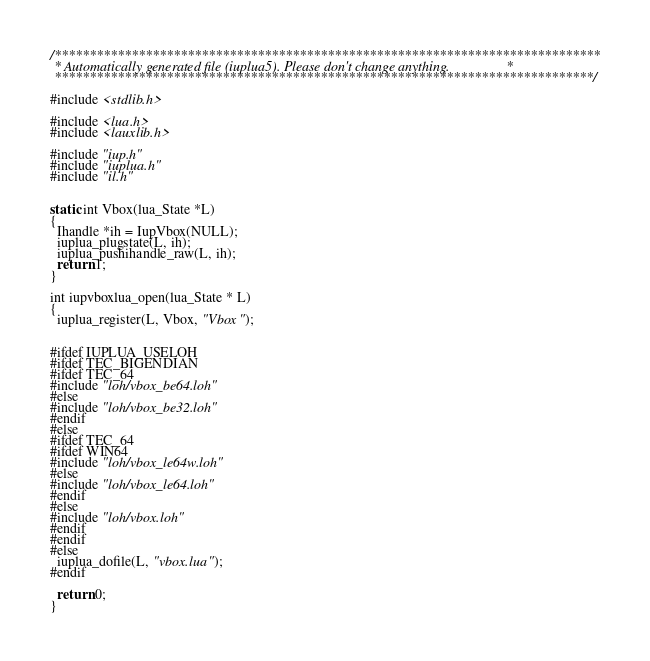<code> <loc_0><loc_0><loc_500><loc_500><_C_>/******************************************************************************
 * Automatically generated file (iuplua5). Please don't change anything.                *
 *****************************************************************************/

#include <stdlib.h>

#include <lua.h>
#include <lauxlib.h>

#include "iup.h"
#include "iuplua.h"
#include "il.h"


static int Vbox(lua_State *L)
{
  Ihandle *ih = IupVbox(NULL);
  iuplua_plugstate(L, ih);
  iuplua_pushihandle_raw(L, ih);
  return 1;
}

int iupvboxlua_open(lua_State * L)
{
  iuplua_register(L, Vbox, "Vbox");


#ifdef IUPLUA_USELOH
#ifdef TEC_BIGENDIAN
#ifdef TEC_64
#include "loh/vbox_be64.loh"
#else
#include "loh/vbox_be32.loh"
#endif
#else
#ifdef TEC_64
#ifdef WIN64
#include "loh/vbox_le64w.loh"
#else
#include "loh/vbox_le64.loh"
#endif
#else
#include "loh/vbox.loh"
#endif
#endif
#else
  iuplua_dofile(L, "vbox.lua");
#endif

  return 0;
}

</code> 